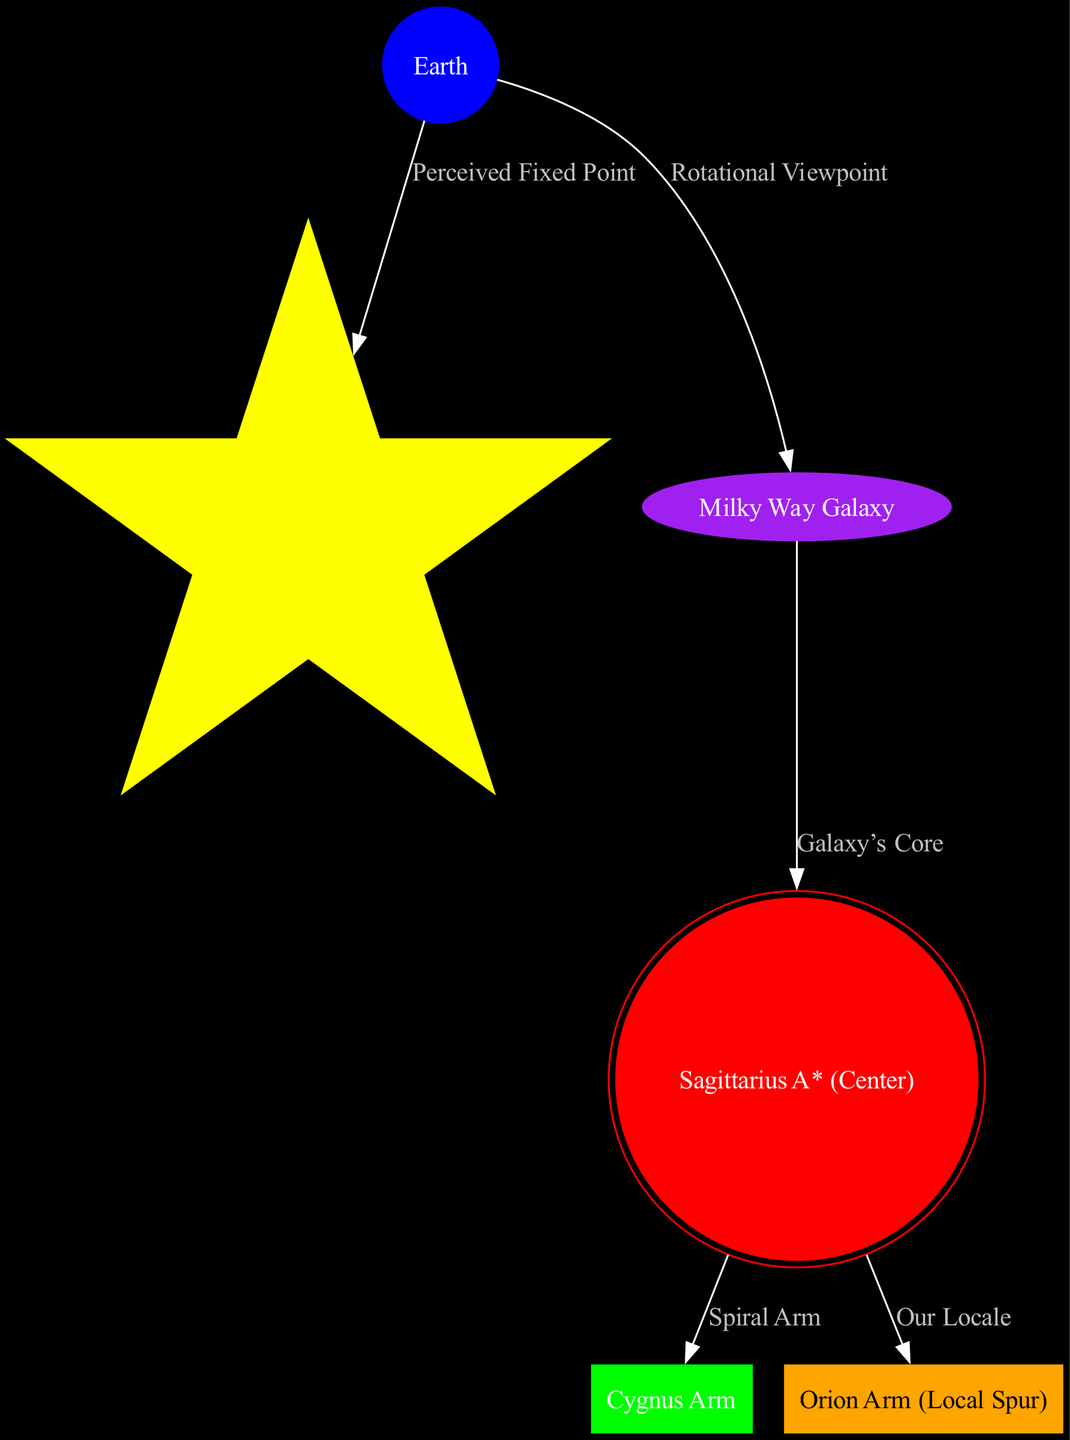What is the fixed point observed from Earth? The diagram indicates that the "Perceived Fixed Point" from Earth is "Polaris (North Star)." This relationship is directly represented by the edge connecting Earth to Polaris.
Answer: Polaris (North Star) How many nodes are present in the diagram? To find the number of nodes, we can simply count each unique node listed in the diagram, which totals six: Earth, Polaris, Milky Way Galaxy, Sagittarius A*, Cygnus Arm, and Orion Arm.
Answer: 6 What color is used to represent Sagittarius A*? The diagram shows Sagittarius A* with the custom color as red, which is specifically assigned in the node styles.
Answer: Red Which arm is labeled as "Our Locale"? Looking at the edges and nodes, we can see that "Orion Arm" is the designated arm referred to with the label "Our Locale," as indicated by the connection from Sagittarius A*.
Answer: Orion Arm What relationship connects the Milky Way to its center? The edge labeled "Galaxy’s Core" connects the Milky Way Galaxy to Sagittarius A*, denoting their relationship. This indicates that Sagittarius A* is at the core of the Milky Way Galaxy.
Answer: Galaxy’s Core Which arm is connected to Sagittarius A* via a spiral edge? The diagram indicates that "Cygnus Arm" is connected to Sagittarius A* through an edge labeled "Spiral Arm." This demonstrates the arrangement of the arms in relation to the galaxy's center.
Answer: Cygnus Arm What is the visual representation shape of Earth? In the diagram, Earth is represented as a circle, as specified in the node styles for that particular node.
Answer: Circle Which star is shown as a perceived fixed point in the diagram? Polaris is shown as the "Perceived Fixed Point" from Earth, clearly stated in the connection from Earth to Polaris.
Answer: Polaris How does the Milky Way connect to Earth visually? The Milky Way connects to Earth through the edge labeled "Rotational Viewpoint," indicating the perspective from which Earth's view of the Milky Way is represented.
Answer: Rotational Viewpoint 